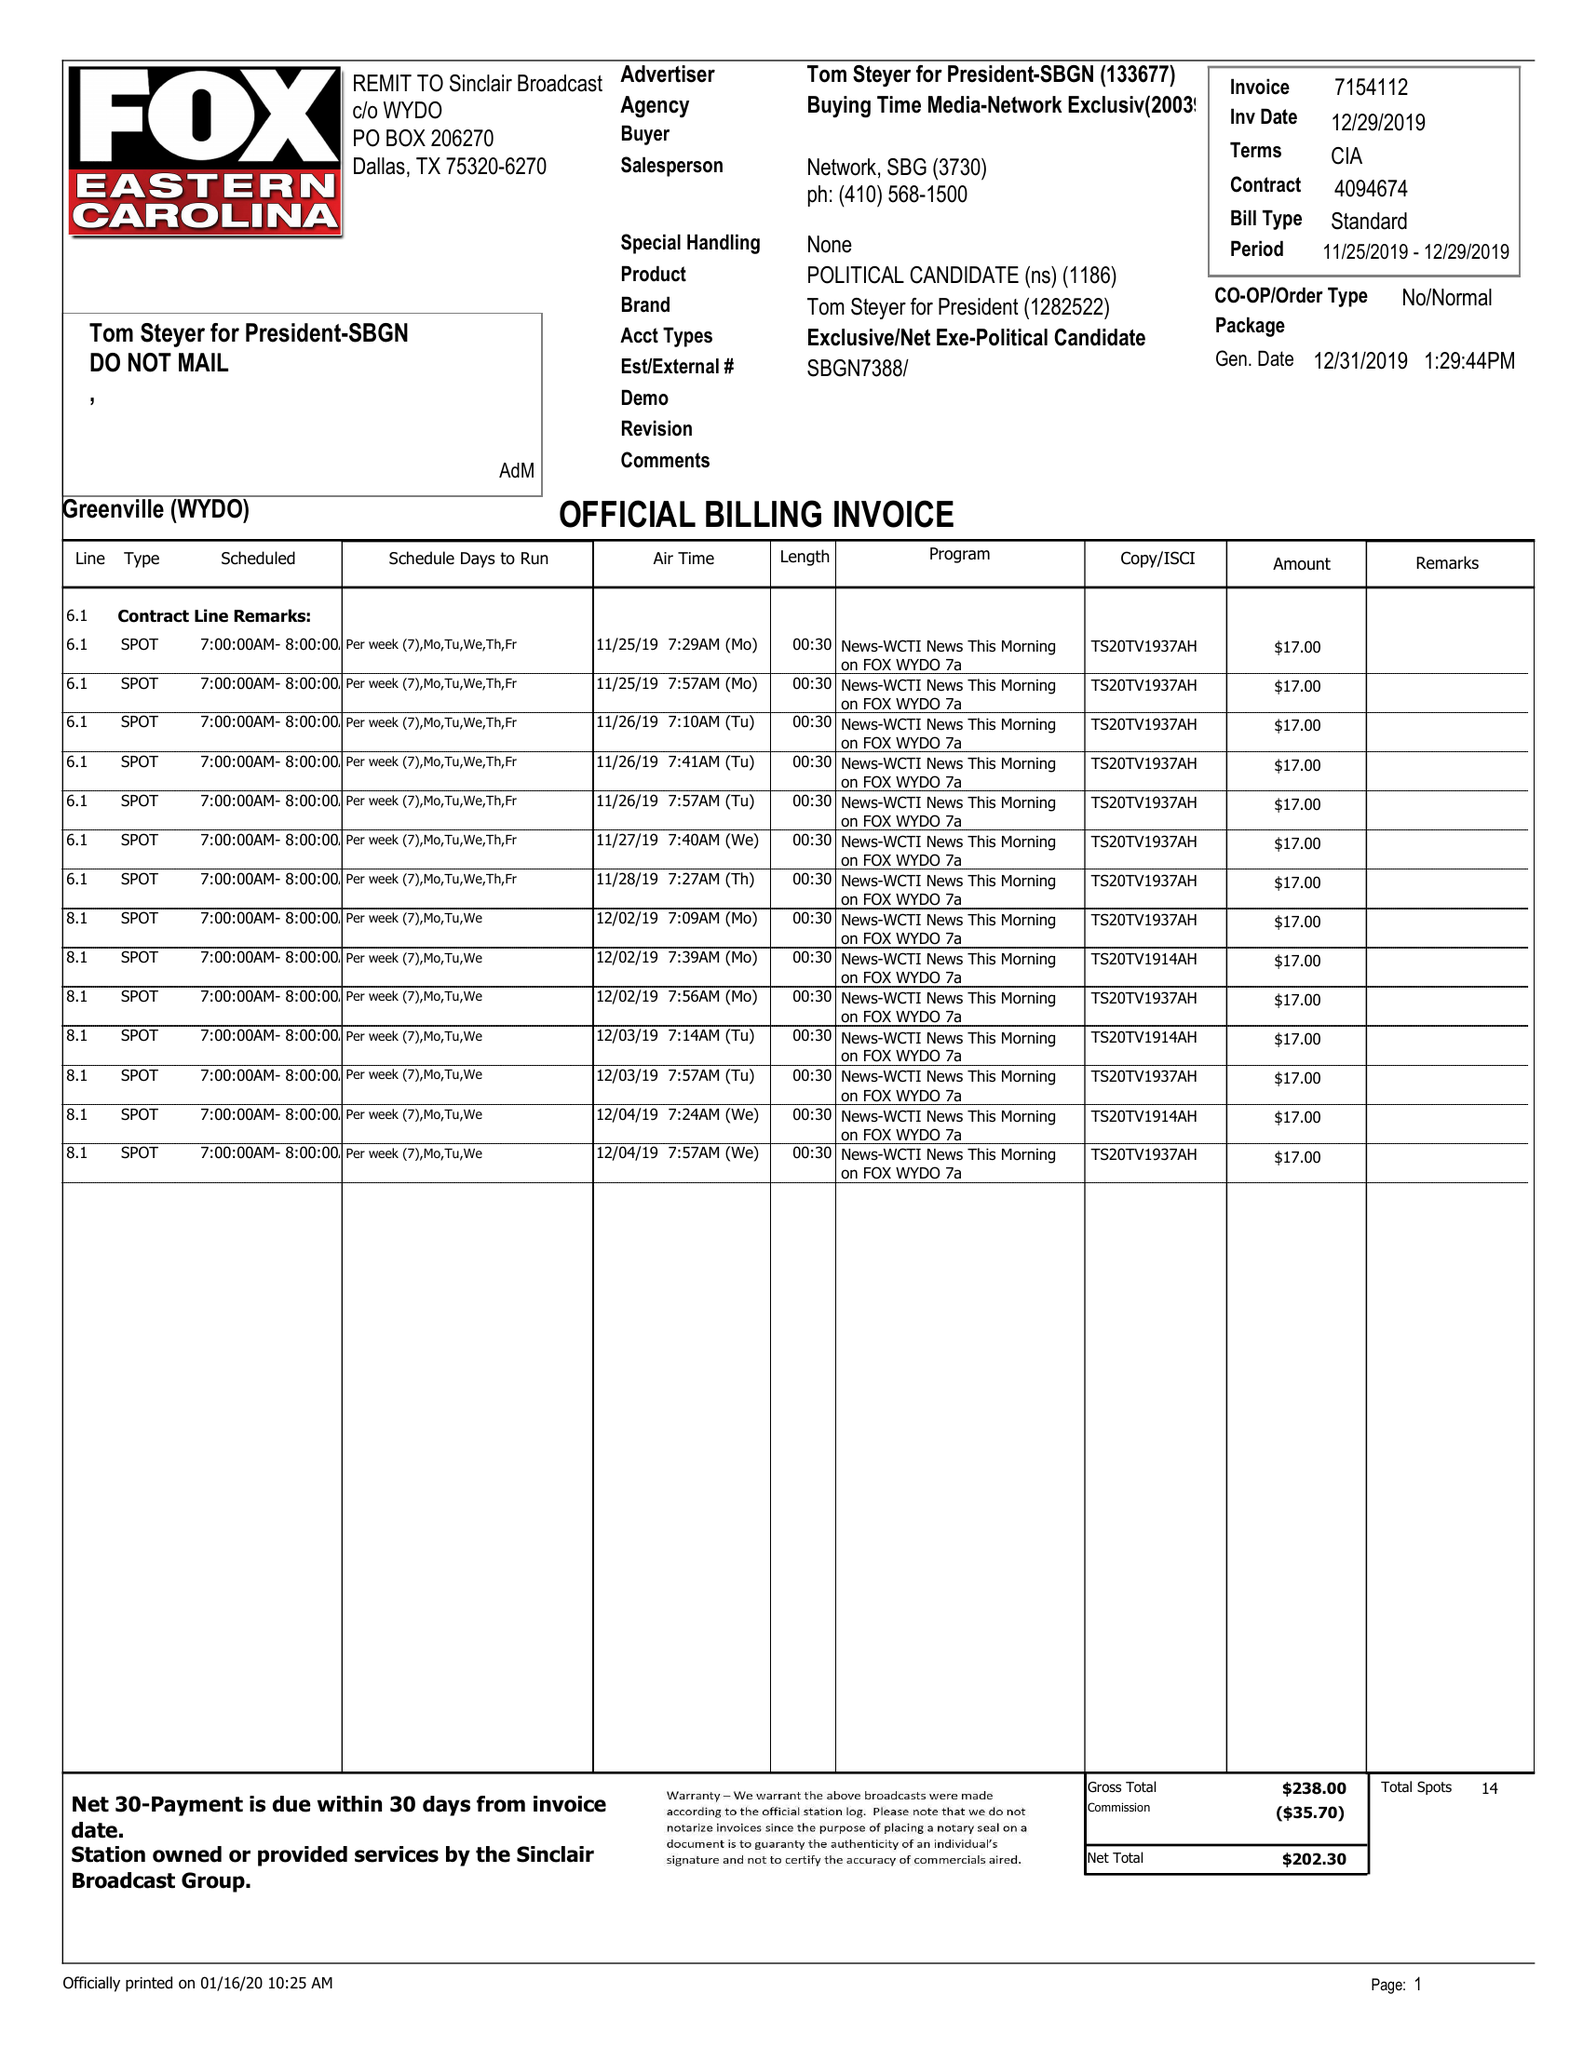What is the value for the contract_num?
Answer the question using a single word or phrase. 4094674 